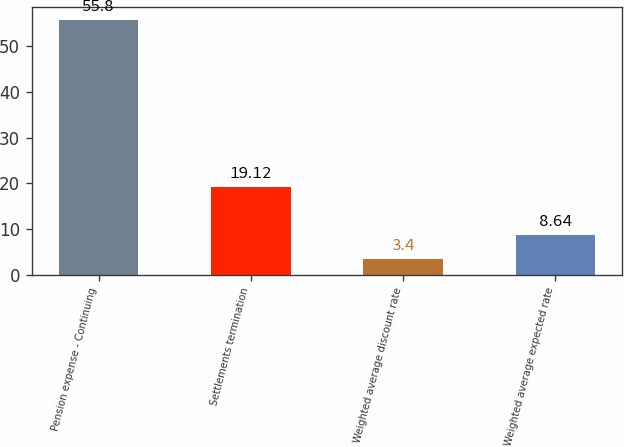Convert chart. <chart><loc_0><loc_0><loc_500><loc_500><bar_chart><fcel>Pension expense - Continuing<fcel>Settlements termination<fcel>Weighted average discount rate<fcel>Weighted average expected rate<nl><fcel>55.8<fcel>19.12<fcel>3.4<fcel>8.64<nl></chart> 